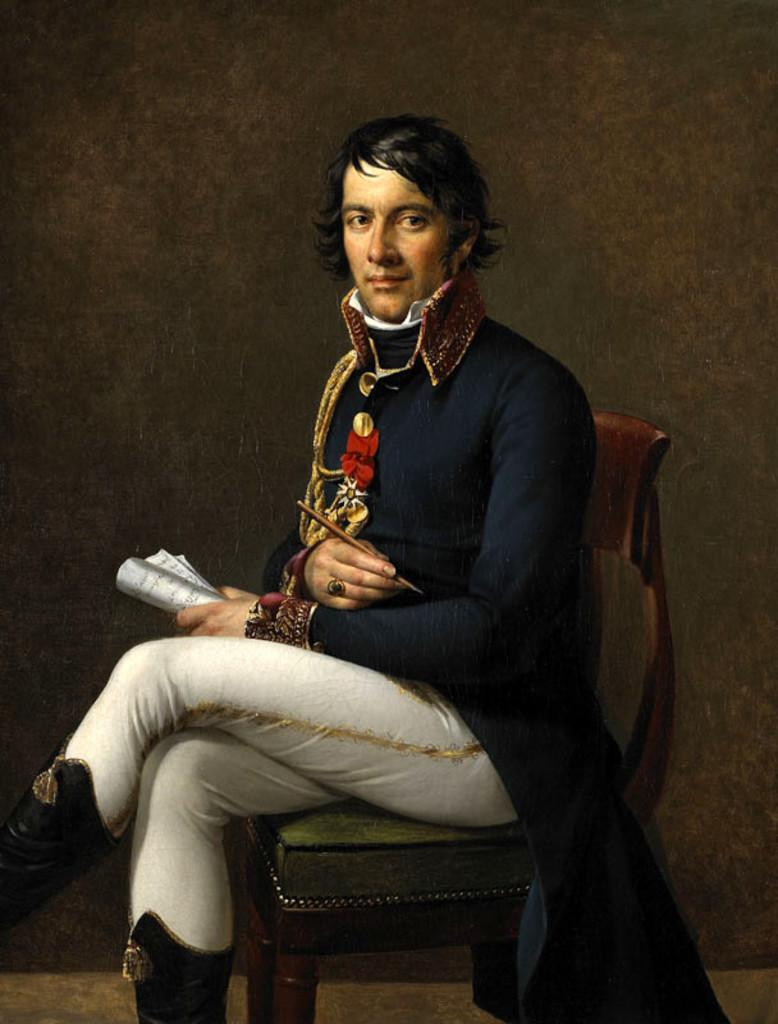What is present in the image that serves as a background or boundary? There is a wall in the image. What is the person in the image doing? The person is sitting on a chair in the image. What flavor of glue is the person using to sleep in the image? There is no glue or indication of sleeping in the image; the person is simply sitting on a chair. 